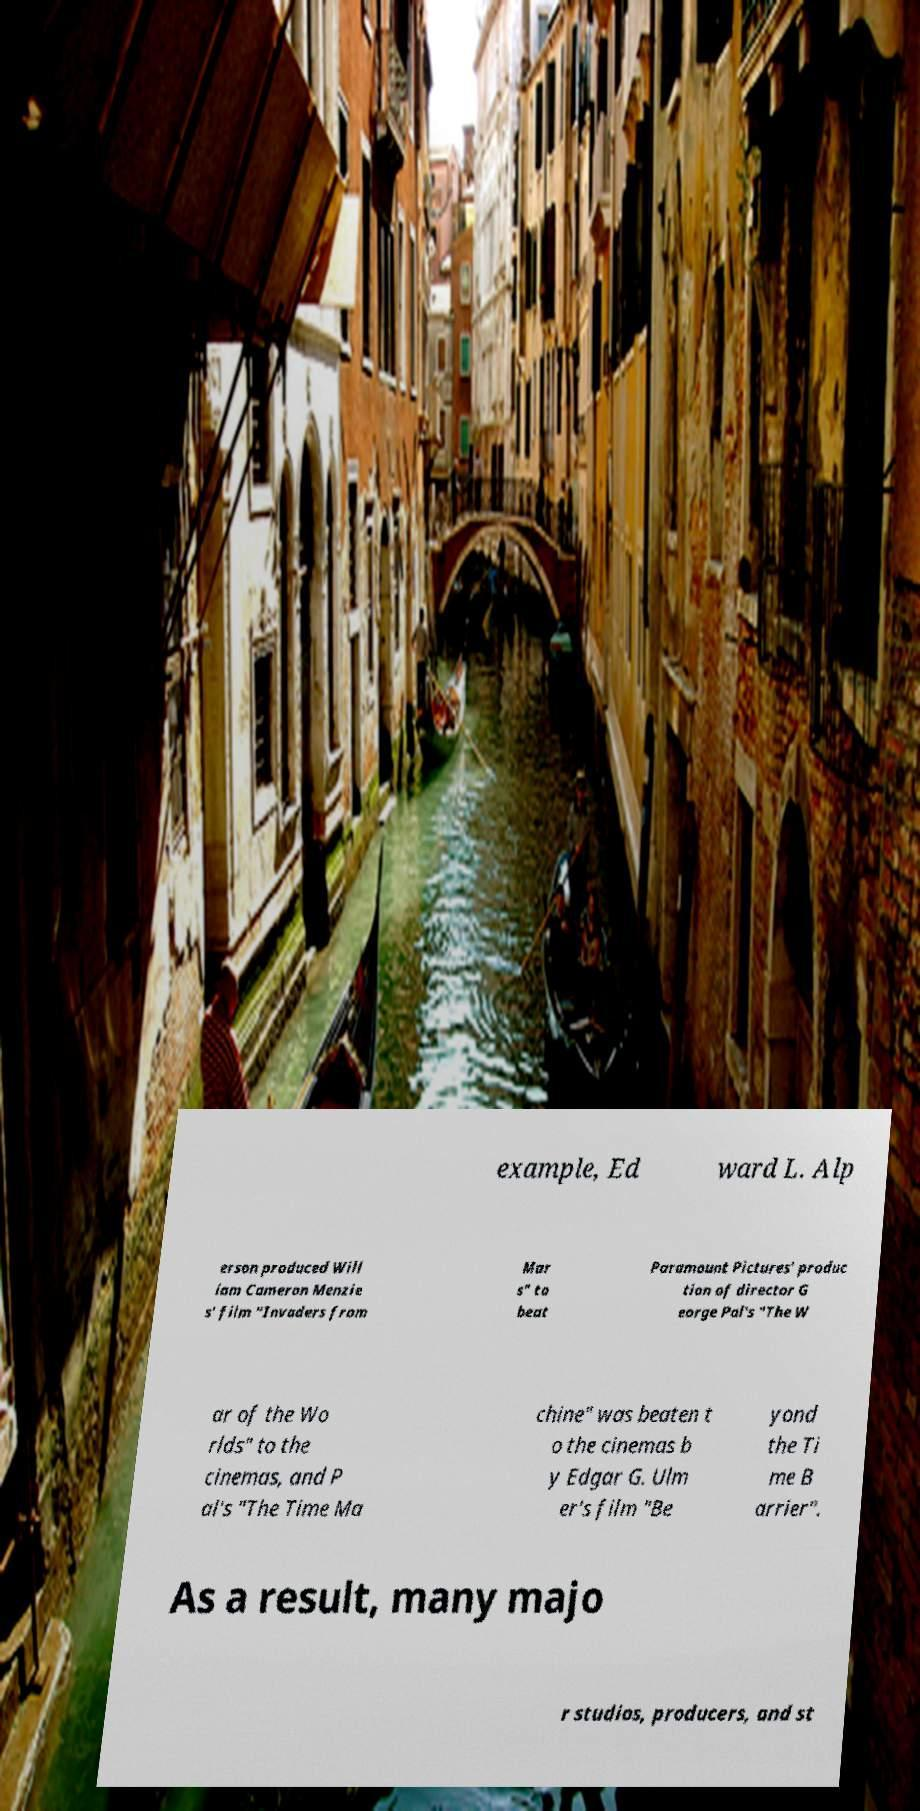I need the written content from this picture converted into text. Can you do that? example, Ed ward L. Alp erson produced Will iam Cameron Menzie s' film "Invaders from Mar s" to beat Paramount Pictures' produc tion of director G eorge Pal's "The W ar of the Wo rlds" to the cinemas, and P al's "The Time Ma chine" was beaten t o the cinemas b y Edgar G. Ulm er's film "Be yond the Ti me B arrier". As a result, many majo r studios, producers, and st 